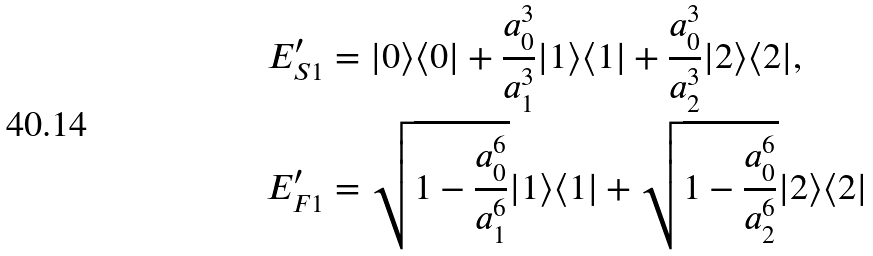Convert formula to latex. <formula><loc_0><loc_0><loc_500><loc_500>E ^ { \prime } _ { S 1 } & = | 0 \rangle \langle 0 | + \frac { a _ { 0 } ^ { 3 } } { a _ { 1 } ^ { 3 } } | 1 \rangle \langle 1 | + \frac { a _ { 0 } ^ { 3 } } { a _ { 2 } ^ { 3 } } | 2 \rangle \langle 2 | , \\ E ^ { \prime } _ { F 1 } & = \sqrt { 1 - \frac { a _ { 0 } ^ { 6 } } { a _ { 1 } ^ { 6 } } } | 1 \rangle \langle 1 | + \sqrt { 1 - \frac { a _ { 0 } ^ { 6 } } { a _ { 2 } ^ { 6 } } } | 2 \rangle \langle 2 |</formula> 